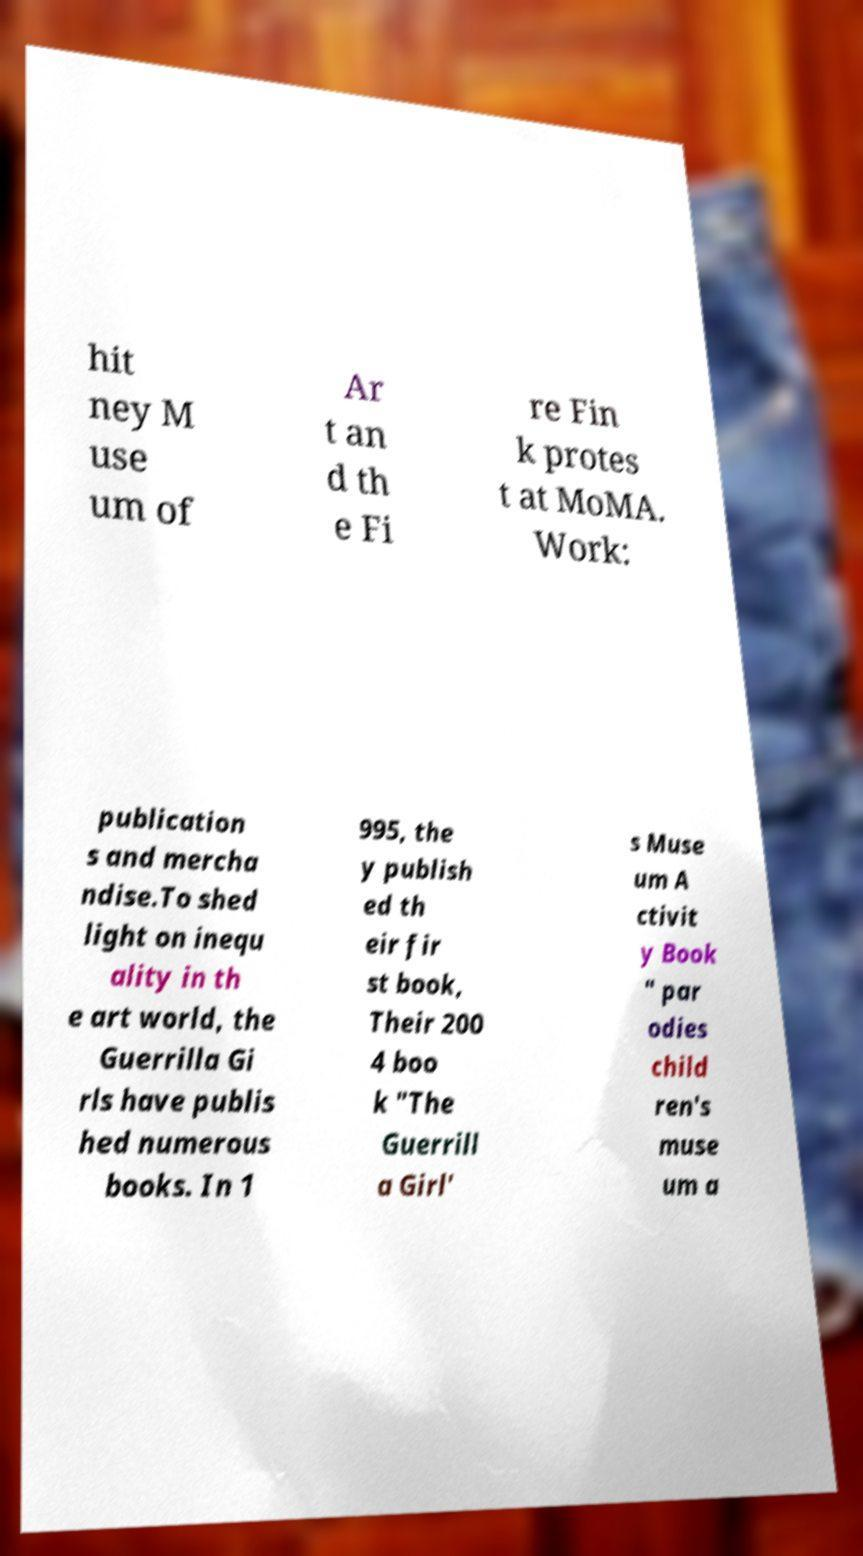Could you extract and type out the text from this image? hit ney M use um of Ar t an d th e Fi re Fin k protes t at MoMA. Work: publication s and mercha ndise.To shed light on inequ ality in th e art world, the Guerrilla Gi rls have publis hed numerous books. In 1 995, the y publish ed th eir fir st book, Their 200 4 boo k "The Guerrill a Girl' s Muse um A ctivit y Book " par odies child ren's muse um a 